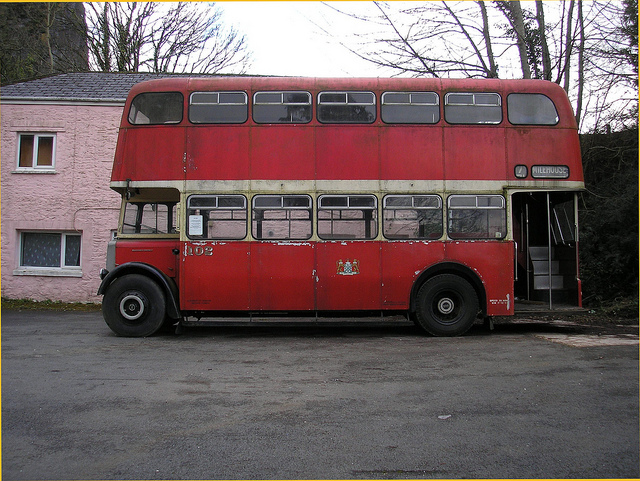Identify the text contained in this image. 102 